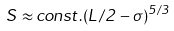Convert formula to latex. <formula><loc_0><loc_0><loc_500><loc_500>S \approx c o n s t . ( L / 2 - \sigma ) ^ { 5 / 3 }</formula> 